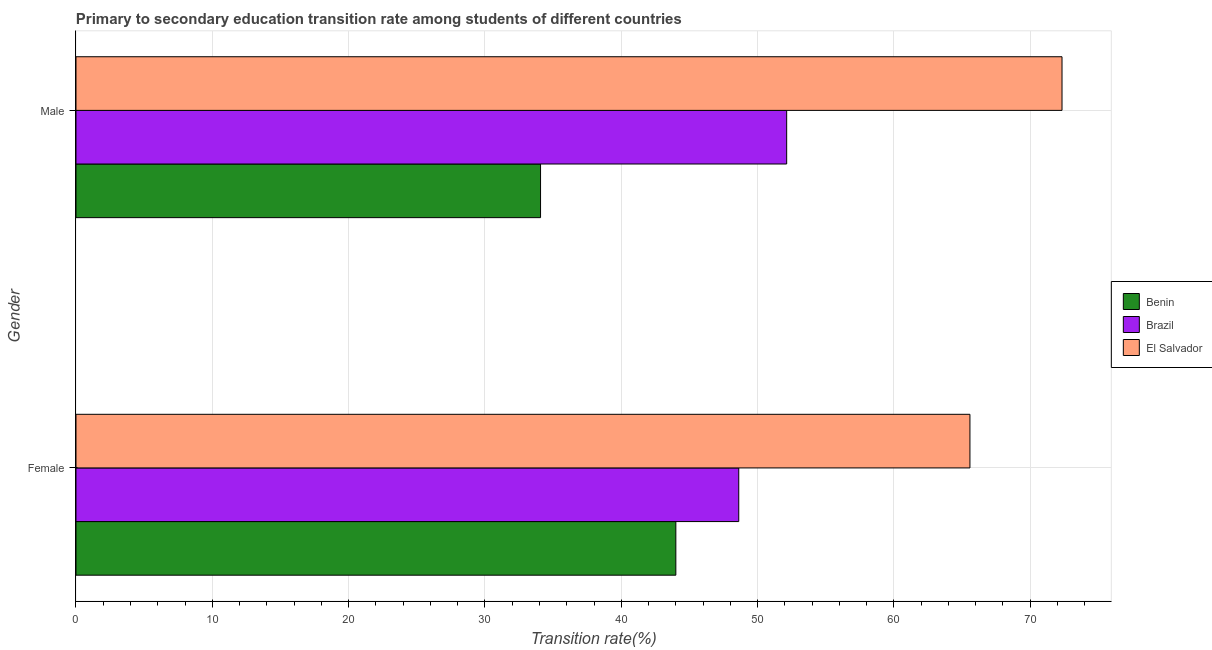How many groups of bars are there?
Keep it short and to the point. 2. What is the label of the 1st group of bars from the top?
Offer a terse response. Male. What is the transition rate among female students in Benin?
Offer a terse response. 44. Across all countries, what is the maximum transition rate among male students?
Provide a succinct answer. 72.33. Across all countries, what is the minimum transition rate among female students?
Ensure brevity in your answer.  44. In which country was the transition rate among female students maximum?
Give a very brief answer. El Salvador. In which country was the transition rate among female students minimum?
Your answer should be compact. Benin. What is the total transition rate among female students in the graph?
Keep it short and to the point. 158.2. What is the difference between the transition rate among male students in Benin and that in El Salvador?
Your answer should be compact. -38.25. What is the difference between the transition rate among female students in Benin and the transition rate among male students in Brazil?
Provide a succinct answer. -8.13. What is the average transition rate among female students per country?
Provide a short and direct response. 52.73. What is the difference between the transition rate among male students and transition rate among female students in El Salvador?
Give a very brief answer. 6.76. In how many countries, is the transition rate among female students greater than 16 %?
Provide a succinct answer. 3. What is the ratio of the transition rate among female students in Brazil to that in Benin?
Your answer should be very brief. 1.1. Is the transition rate among female students in El Salvador less than that in Brazil?
Keep it short and to the point. No. In how many countries, is the transition rate among female students greater than the average transition rate among female students taken over all countries?
Keep it short and to the point. 1. What does the 3rd bar from the top in Female represents?
Give a very brief answer. Benin. How many bars are there?
Give a very brief answer. 6. How many countries are there in the graph?
Keep it short and to the point. 3. What is the difference between two consecutive major ticks on the X-axis?
Give a very brief answer. 10. Where does the legend appear in the graph?
Make the answer very short. Center right. How many legend labels are there?
Offer a very short reply. 3. How are the legend labels stacked?
Give a very brief answer. Vertical. What is the title of the graph?
Provide a short and direct response. Primary to secondary education transition rate among students of different countries. What is the label or title of the X-axis?
Provide a short and direct response. Transition rate(%). What is the label or title of the Y-axis?
Provide a succinct answer. Gender. What is the Transition rate(%) of Benin in Female?
Provide a succinct answer. 44. What is the Transition rate(%) of Brazil in Female?
Offer a very short reply. 48.62. What is the Transition rate(%) of El Salvador in Female?
Provide a succinct answer. 65.58. What is the Transition rate(%) of Benin in Male?
Offer a terse response. 34.08. What is the Transition rate(%) in Brazil in Male?
Your answer should be compact. 52.13. What is the Transition rate(%) in El Salvador in Male?
Provide a short and direct response. 72.33. Across all Gender, what is the maximum Transition rate(%) in Benin?
Give a very brief answer. 44. Across all Gender, what is the maximum Transition rate(%) in Brazil?
Offer a terse response. 52.13. Across all Gender, what is the maximum Transition rate(%) in El Salvador?
Provide a short and direct response. 72.33. Across all Gender, what is the minimum Transition rate(%) in Benin?
Your response must be concise. 34.08. Across all Gender, what is the minimum Transition rate(%) of Brazil?
Give a very brief answer. 48.62. Across all Gender, what is the minimum Transition rate(%) in El Salvador?
Provide a succinct answer. 65.58. What is the total Transition rate(%) of Benin in the graph?
Ensure brevity in your answer.  78.08. What is the total Transition rate(%) of Brazil in the graph?
Your answer should be very brief. 100.75. What is the total Transition rate(%) of El Salvador in the graph?
Your answer should be compact. 137.91. What is the difference between the Transition rate(%) of Benin in Female and that in Male?
Keep it short and to the point. 9.92. What is the difference between the Transition rate(%) in Brazil in Female and that in Male?
Provide a short and direct response. -3.51. What is the difference between the Transition rate(%) in El Salvador in Female and that in Male?
Your answer should be very brief. -6.76. What is the difference between the Transition rate(%) in Benin in Female and the Transition rate(%) in Brazil in Male?
Your answer should be very brief. -8.13. What is the difference between the Transition rate(%) in Benin in Female and the Transition rate(%) in El Salvador in Male?
Your answer should be compact. -28.33. What is the difference between the Transition rate(%) in Brazil in Female and the Transition rate(%) in El Salvador in Male?
Your answer should be very brief. -23.71. What is the average Transition rate(%) in Benin per Gender?
Give a very brief answer. 39.04. What is the average Transition rate(%) of Brazil per Gender?
Provide a succinct answer. 50.38. What is the average Transition rate(%) in El Salvador per Gender?
Ensure brevity in your answer.  68.95. What is the difference between the Transition rate(%) of Benin and Transition rate(%) of Brazil in Female?
Keep it short and to the point. -4.61. What is the difference between the Transition rate(%) in Benin and Transition rate(%) in El Salvador in Female?
Keep it short and to the point. -21.57. What is the difference between the Transition rate(%) in Brazil and Transition rate(%) in El Salvador in Female?
Provide a short and direct response. -16.96. What is the difference between the Transition rate(%) of Benin and Transition rate(%) of Brazil in Male?
Provide a short and direct response. -18.05. What is the difference between the Transition rate(%) in Benin and Transition rate(%) in El Salvador in Male?
Provide a short and direct response. -38.25. What is the difference between the Transition rate(%) of Brazil and Transition rate(%) of El Salvador in Male?
Your response must be concise. -20.2. What is the ratio of the Transition rate(%) in Benin in Female to that in Male?
Keep it short and to the point. 1.29. What is the ratio of the Transition rate(%) in Brazil in Female to that in Male?
Provide a succinct answer. 0.93. What is the ratio of the Transition rate(%) of El Salvador in Female to that in Male?
Offer a terse response. 0.91. What is the difference between the highest and the second highest Transition rate(%) in Benin?
Your response must be concise. 9.92. What is the difference between the highest and the second highest Transition rate(%) of Brazil?
Offer a terse response. 3.51. What is the difference between the highest and the second highest Transition rate(%) of El Salvador?
Make the answer very short. 6.76. What is the difference between the highest and the lowest Transition rate(%) of Benin?
Your response must be concise. 9.92. What is the difference between the highest and the lowest Transition rate(%) of Brazil?
Give a very brief answer. 3.51. What is the difference between the highest and the lowest Transition rate(%) of El Salvador?
Provide a short and direct response. 6.76. 